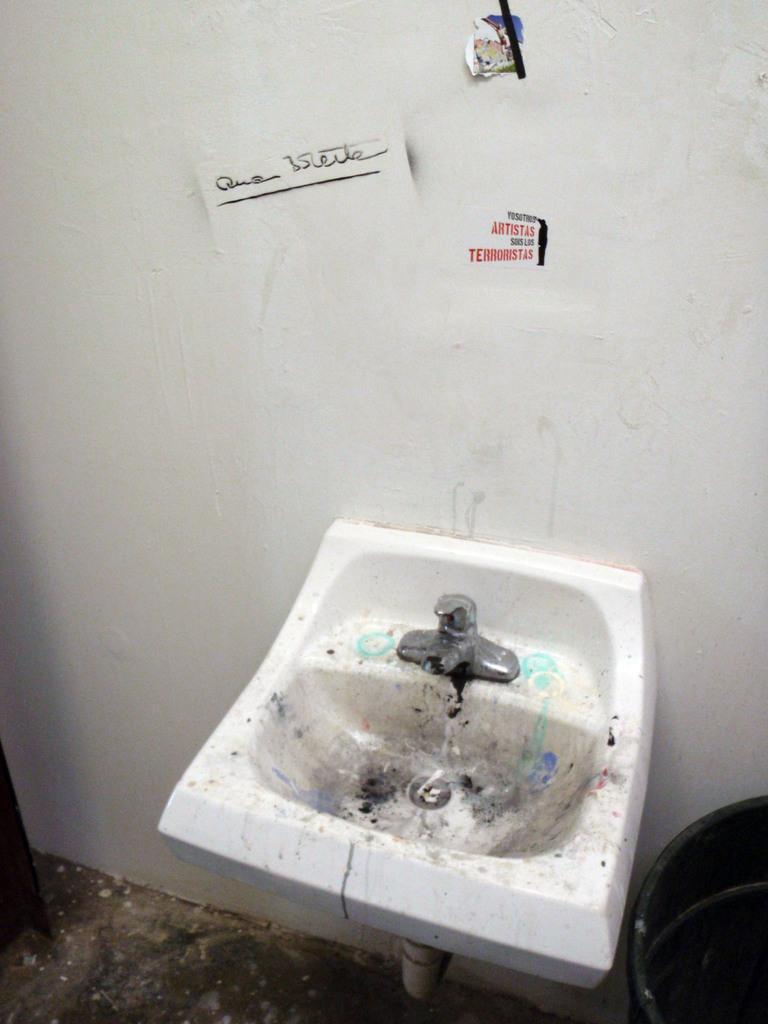Can you describe this image briefly? In this image I can see the wash basin and the tap and I can also see few objects on the wall and the wall is in white color. 